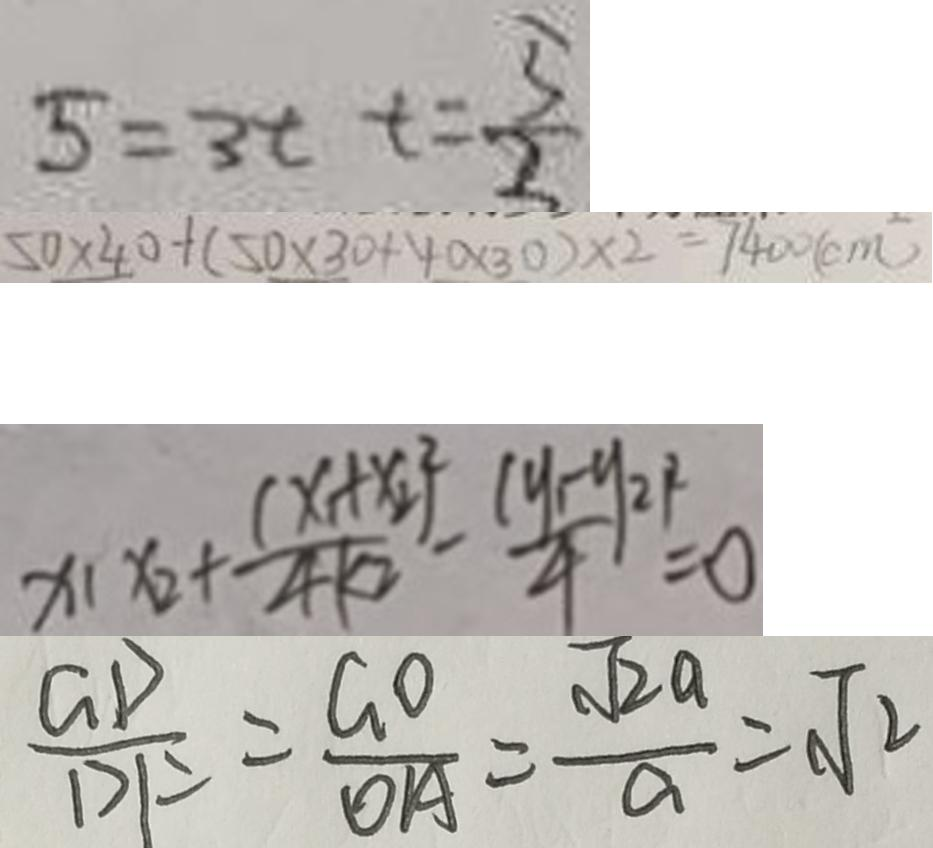Convert formula to latex. <formula><loc_0><loc_0><loc_500><loc_500>5 = 3 t t = \frac { 5 } { 2 } 
 5 0 \times 4 0 + ( 5 0 \times 3 0 + 4 0 \times 3 0 ) \times 2 = 7 4 0 0 ( c m ^ { 2 } ) 
 x _ { 1 } x _ { 2 } + \frac { ( x _ { 1 } + x _ { 2 } ) ^ { 2 } } { 4 k ^ { 2 } } - \frac { ( y _ { 1 } - y _ { 2 } ) ^ { 2 } } { 4 } = 0 
 \frac { G D } { D F } = \frac { G O } { O A } = \frac { \sqrt { 2 a } } { a } = \sqrt { 2 }</formula> 